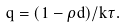<formula> <loc_0><loc_0><loc_500><loc_500>q = ( 1 - \rho d ) / k \tau .</formula> 